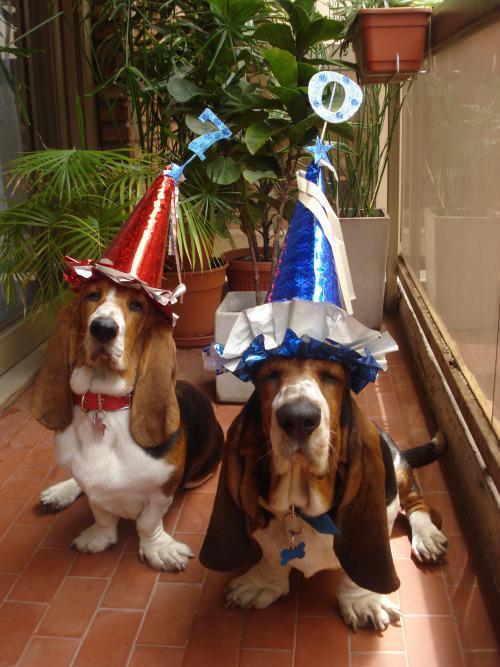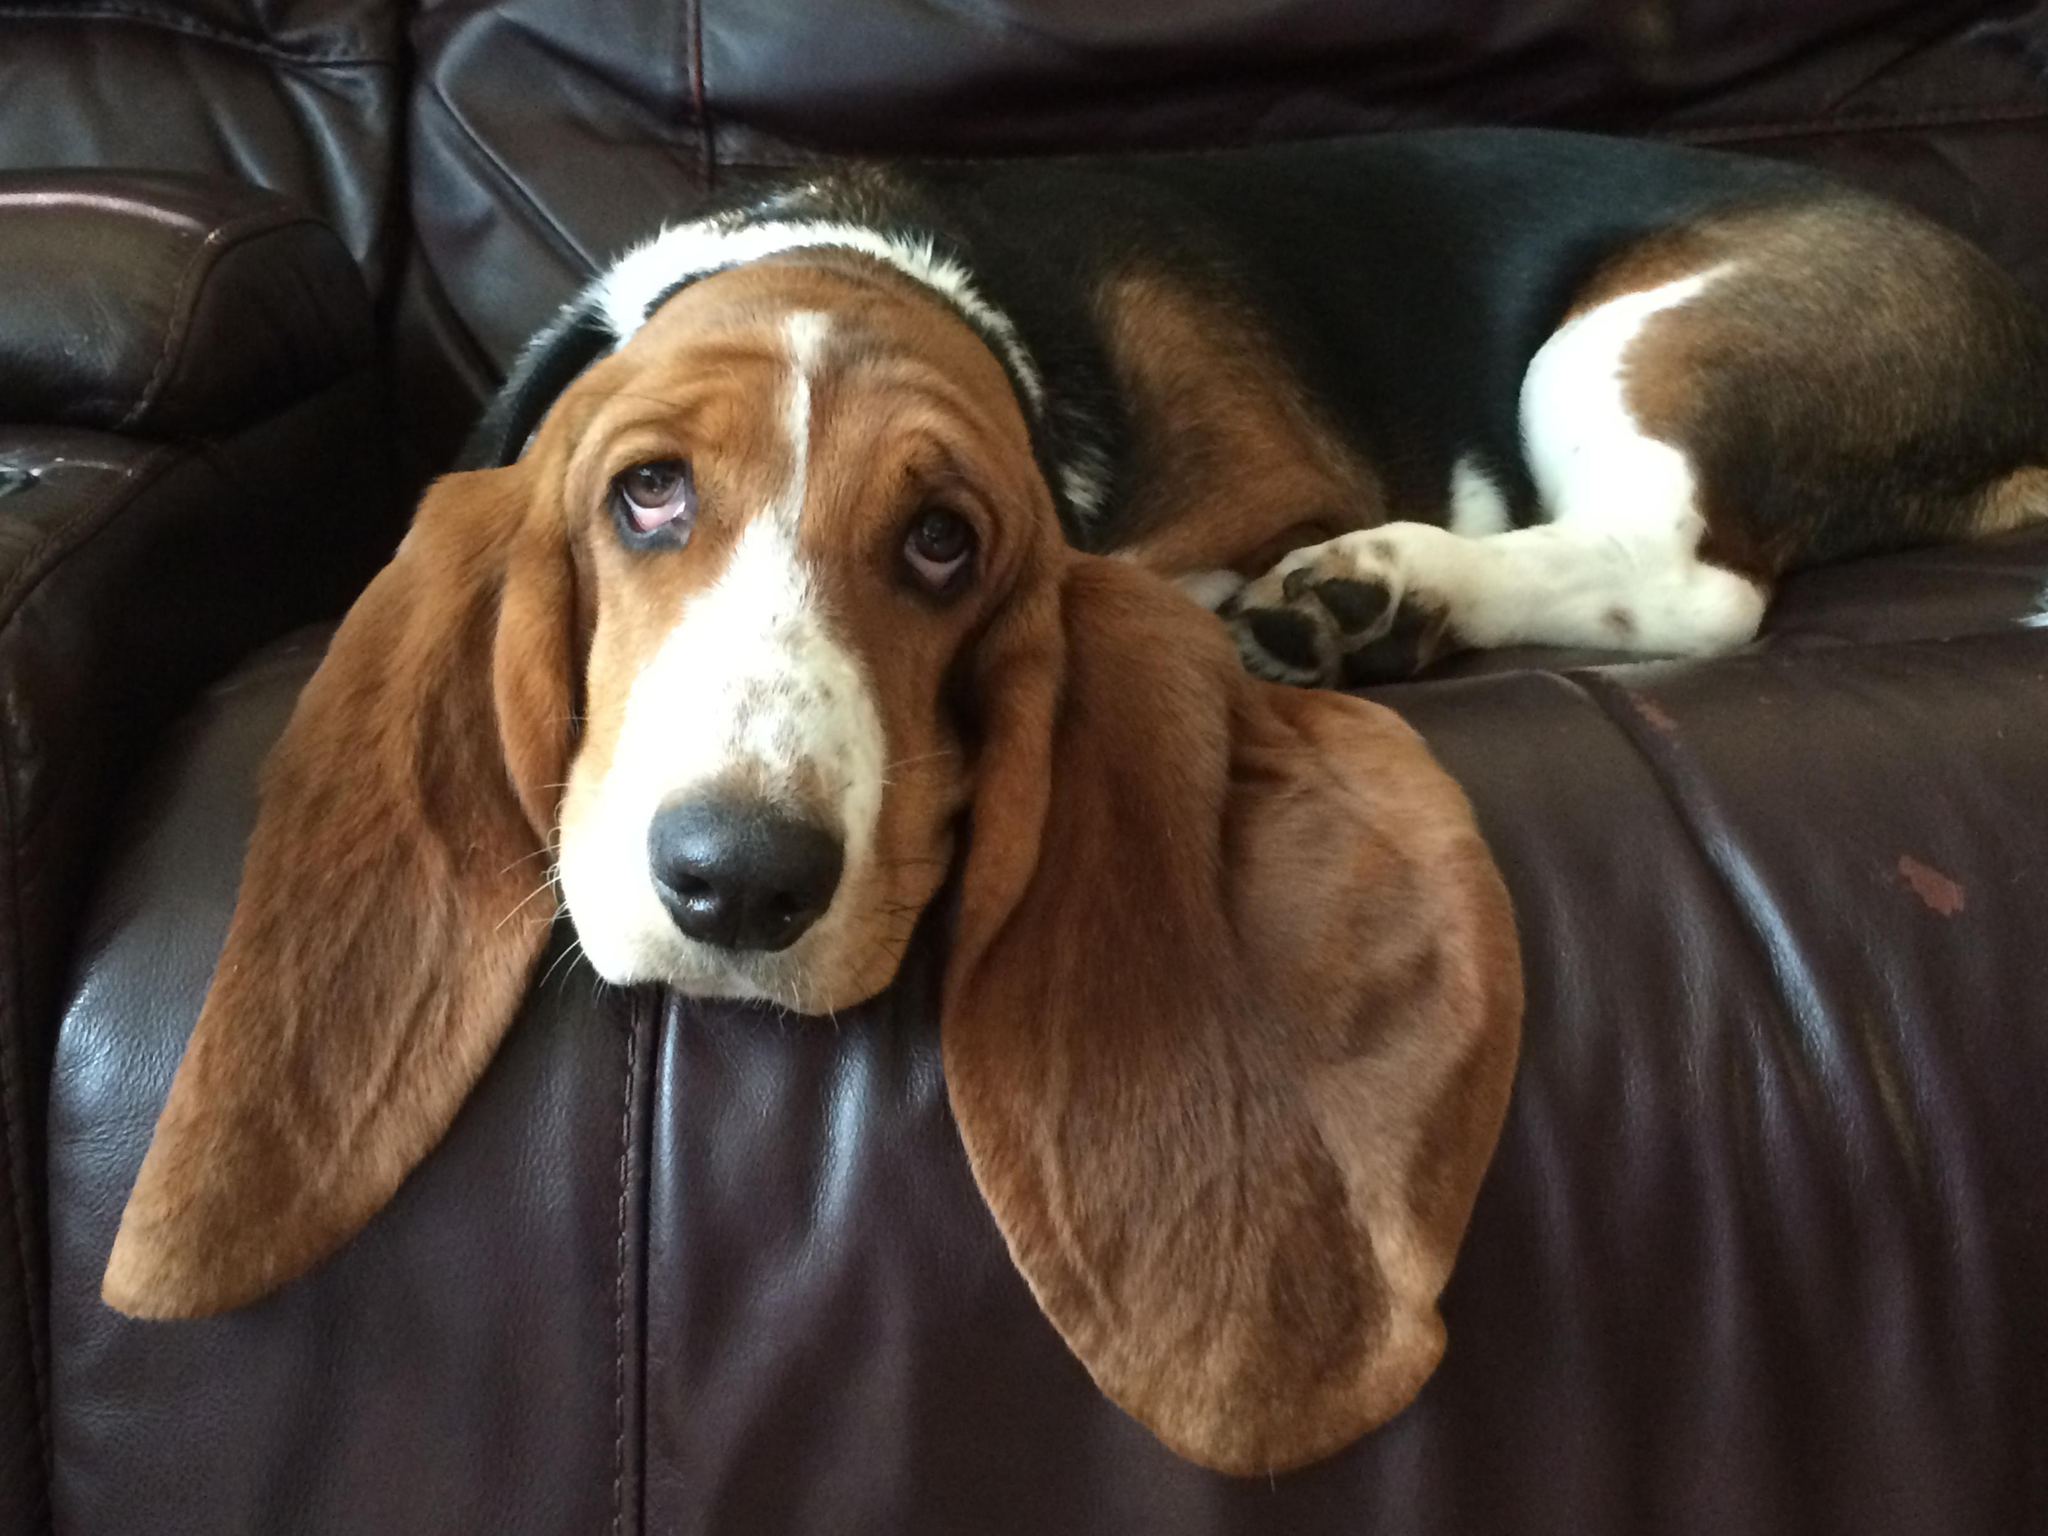The first image is the image on the left, the second image is the image on the right. Evaluate the accuracy of this statement regarding the images: "One image with at least one camera-facing basset hound in it also contains two hats.". Is it true? Answer yes or no. Yes. The first image is the image on the left, the second image is the image on the right. For the images displayed, is the sentence "In one of the images two mammals can be seen wearing hats." factually correct? Answer yes or no. Yes. 